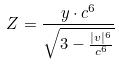<formula> <loc_0><loc_0><loc_500><loc_500>Z = \frac { y \cdot c ^ { 6 } } { \sqrt { 3 - \frac { | v | ^ { 6 } } { c ^ { 6 } } } }</formula> 